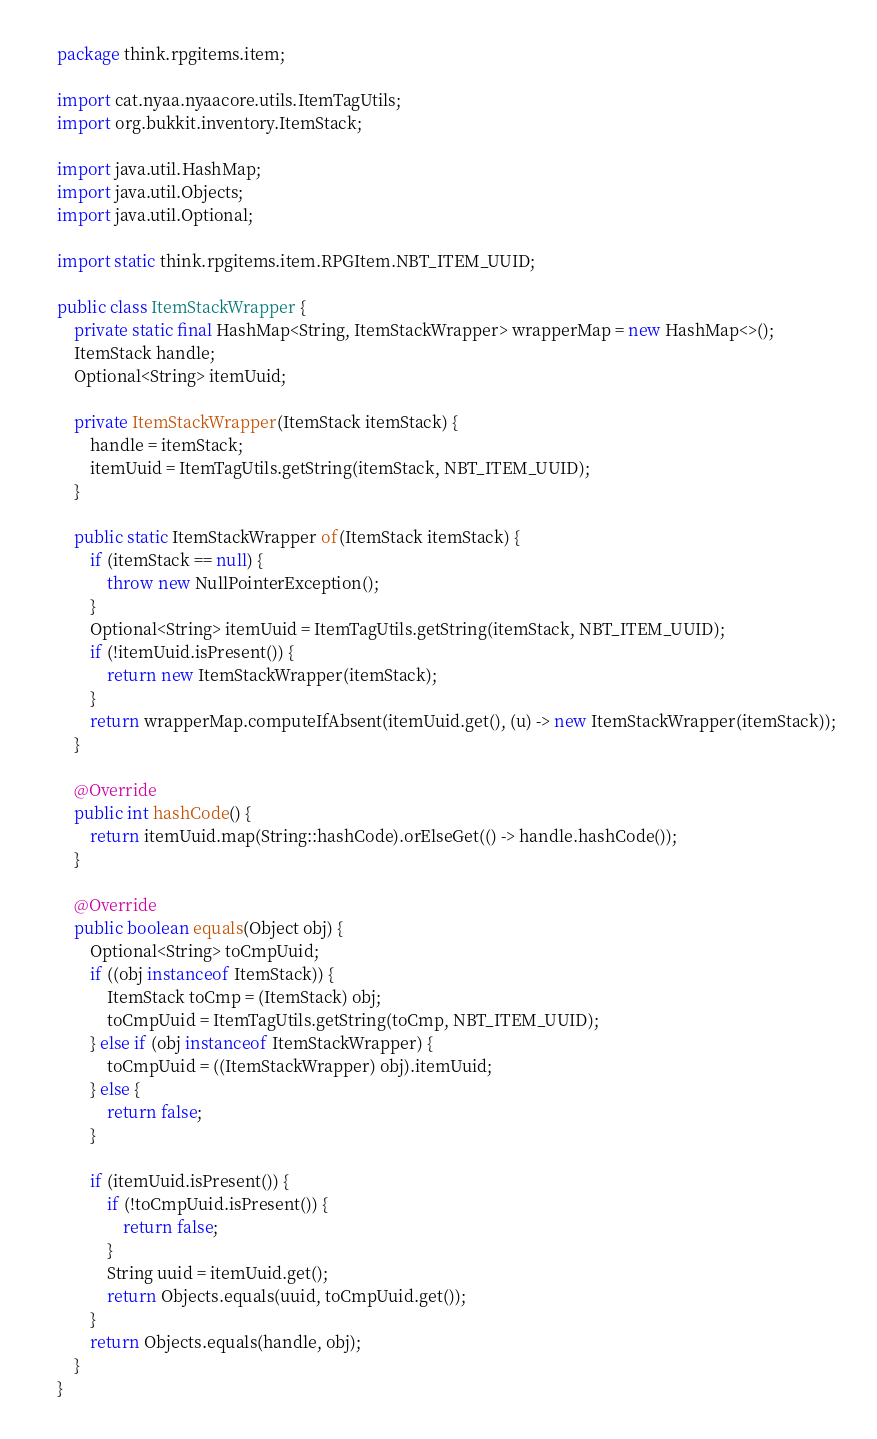Convert code to text. <code><loc_0><loc_0><loc_500><loc_500><_Java_>package think.rpgitems.item;

import cat.nyaa.nyaacore.utils.ItemTagUtils;
import org.bukkit.inventory.ItemStack;

import java.util.HashMap;
import java.util.Objects;
import java.util.Optional;

import static think.rpgitems.item.RPGItem.NBT_ITEM_UUID;

public class ItemStackWrapper {
    private static final HashMap<String, ItemStackWrapper> wrapperMap = new HashMap<>();
    ItemStack handle;
    Optional<String> itemUuid;

    private ItemStackWrapper(ItemStack itemStack) {
        handle = itemStack;
        itemUuid = ItemTagUtils.getString(itemStack, NBT_ITEM_UUID);
    }

    public static ItemStackWrapper of(ItemStack itemStack) {
        if (itemStack == null) {
            throw new NullPointerException();
        }
        Optional<String> itemUuid = ItemTagUtils.getString(itemStack, NBT_ITEM_UUID);
        if (!itemUuid.isPresent()) {
            return new ItemStackWrapper(itemStack);
        }
        return wrapperMap.computeIfAbsent(itemUuid.get(), (u) -> new ItemStackWrapper(itemStack));
    }

    @Override
    public int hashCode() {
        return itemUuid.map(String::hashCode).orElseGet(() -> handle.hashCode());
    }

    @Override
    public boolean equals(Object obj) {
        Optional<String> toCmpUuid;
        if ((obj instanceof ItemStack)) {
            ItemStack toCmp = (ItemStack) obj;
            toCmpUuid = ItemTagUtils.getString(toCmp, NBT_ITEM_UUID);
        } else if (obj instanceof ItemStackWrapper) {
            toCmpUuid = ((ItemStackWrapper) obj).itemUuid;
        } else {
            return false;
        }

        if (itemUuid.isPresent()) {
            if (!toCmpUuid.isPresent()) {
                return false;
            }
            String uuid = itemUuid.get();
            return Objects.equals(uuid, toCmpUuid.get());
        }
        return Objects.equals(handle, obj);
    }
}
</code> 